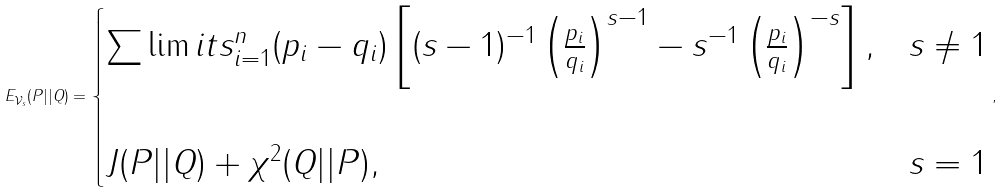Convert formula to latex. <formula><loc_0><loc_0><loc_500><loc_500>E _ { \mathcal { V } _ { s } } ( P | | Q ) = \begin{cases} { \sum \lim i t s _ { i = 1 } ^ { n } { ( p _ { i } - q _ { i } ) \left [ { ( s - 1 ) ^ { - 1 } \left ( { \frac { p _ { i } } { q _ { i } } } \right ) ^ { s - 1 } - s ^ { - 1 } \left ( { \frac { p _ { i } } { q _ { i } } } \right ) ^ { - s } } \right ] , } } & { s \ne 1 } \\ \\ { J ( P | | Q ) + \chi ^ { 2 } ( Q | | P ) , } & { s = 1 } \\ \end{cases} ,</formula> 